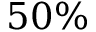<formula> <loc_0><loc_0><loc_500><loc_500>5 0 \%</formula> 